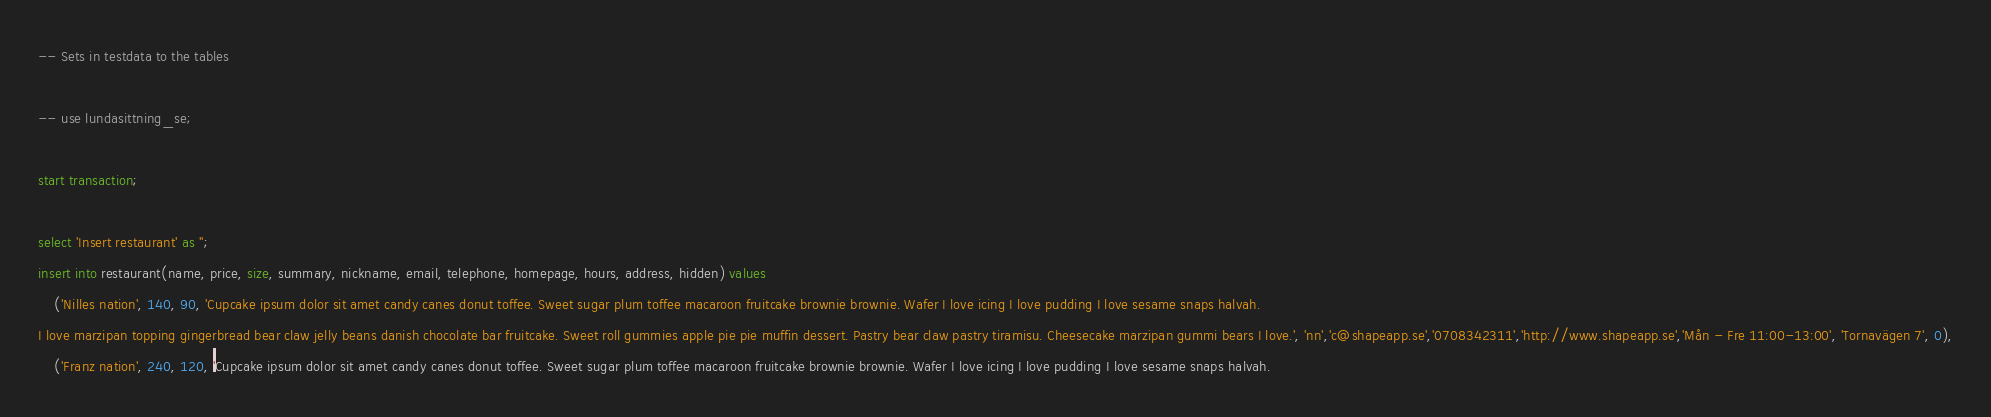<code> <loc_0><loc_0><loc_500><loc_500><_SQL_>-- Sets in testdata to the tables

-- use lundasittning_se;

start transaction;

select 'Insert restaurant' as '';
insert into restaurant(name, price, size, summary, nickname, email, telephone, homepage, hours, address, hidden) values
    ('Nilles nation', 140, 90, 'Cupcake ipsum dolor sit amet candy canes donut toffee. Sweet sugar plum toffee macaroon fruitcake brownie brownie. Wafer I love icing I love pudding I love sesame snaps halvah.
I love marzipan topping gingerbread bear claw jelly beans danish chocolate bar fruitcake. Sweet roll gummies apple pie pie muffin dessert. Pastry bear claw pastry tiramisu. Cheesecake marzipan gummi bears I love.', 'nn','c@shapeapp.se','0708342311','http://www.shapeapp.se','Mån - Fre 11:00-13:00', 'Tornavägen 7', 0),
    ('Franz nation', 240, 120, 'Cupcake ipsum dolor sit amet candy canes donut toffee. Sweet sugar plum toffee macaroon fruitcake brownie brownie. Wafer I love icing I love pudding I love sesame snaps halvah.</code> 